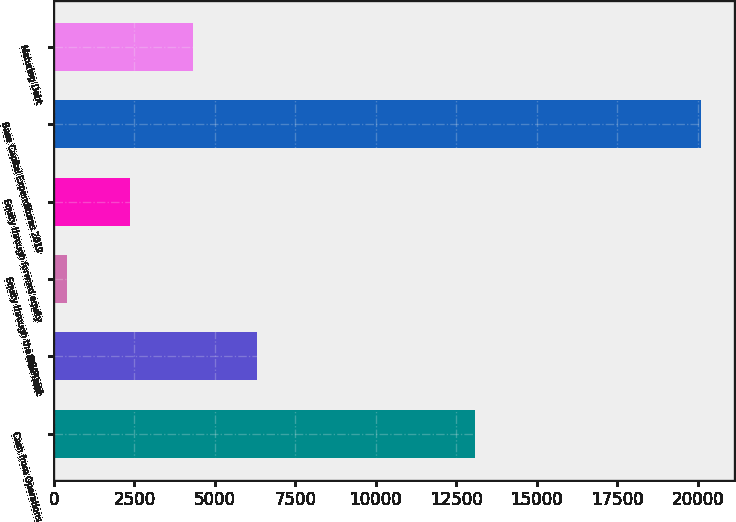Convert chart to OTSL. <chart><loc_0><loc_0><loc_500><loc_500><bar_chart><fcel>Cash from Operations<fcel>New Debt<fcel>Equity through the DRIP and<fcel>Equity through forward equity<fcel>Base Capital Expenditures 2019<fcel>Maturing Debt<nl><fcel>13070<fcel>6306<fcel>390<fcel>2362<fcel>20110<fcel>4334<nl></chart> 